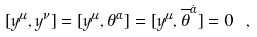Convert formula to latex. <formula><loc_0><loc_0><loc_500><loc_500>[ y ^ { \mu } , y ^ { \nu } ] = [ y ^ { \mu } , { \theta } ^ { \alpha } ] = [ y ^ { \mu } , { \overline { \theta } } ^ { \dot { \alpha } } ] = 0 \ ,</formula> 